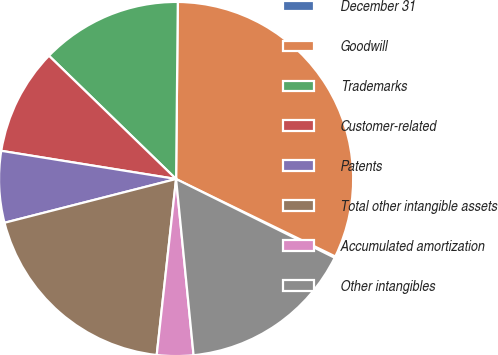Convert chart. <chart><loc_0><loc_0><loc_500><loc_500><pie_chart><fcel>December 31<fcel>Goodwill<fcel>Trademarks<fcel>Customer-related<fcel>Patents<fcel>Total other intangible assets<fcel>Accumulated amortization<fcel>Other intangibles<nl><fcel>0.13%<fcel>32.05%<fcel>12.9%<fcel>9.71%<fcel>6.52%<fcel>19.28%<fcel>3.32%<fcel>16.09%<nl></chart> 